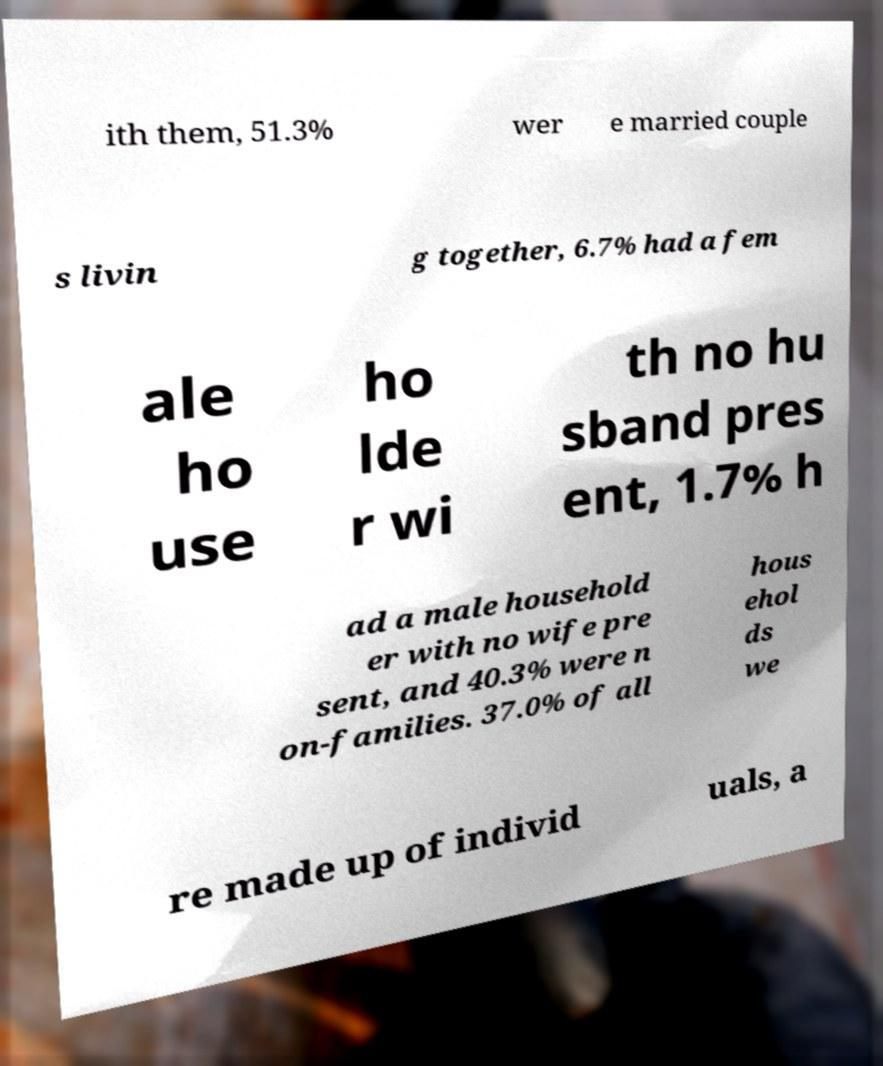Could you extract and type out the text from this image? ith them, 51.3% wer e married couple s livin g together, 6.7% had a fem ale ho use ho lde r wi th no hu sband pres ent, 1.7% h ad a male household er with no wife pre sent, and 40.3% were n on-families. 37.0% of all hous ehol ds we re made up of individ uals, a 